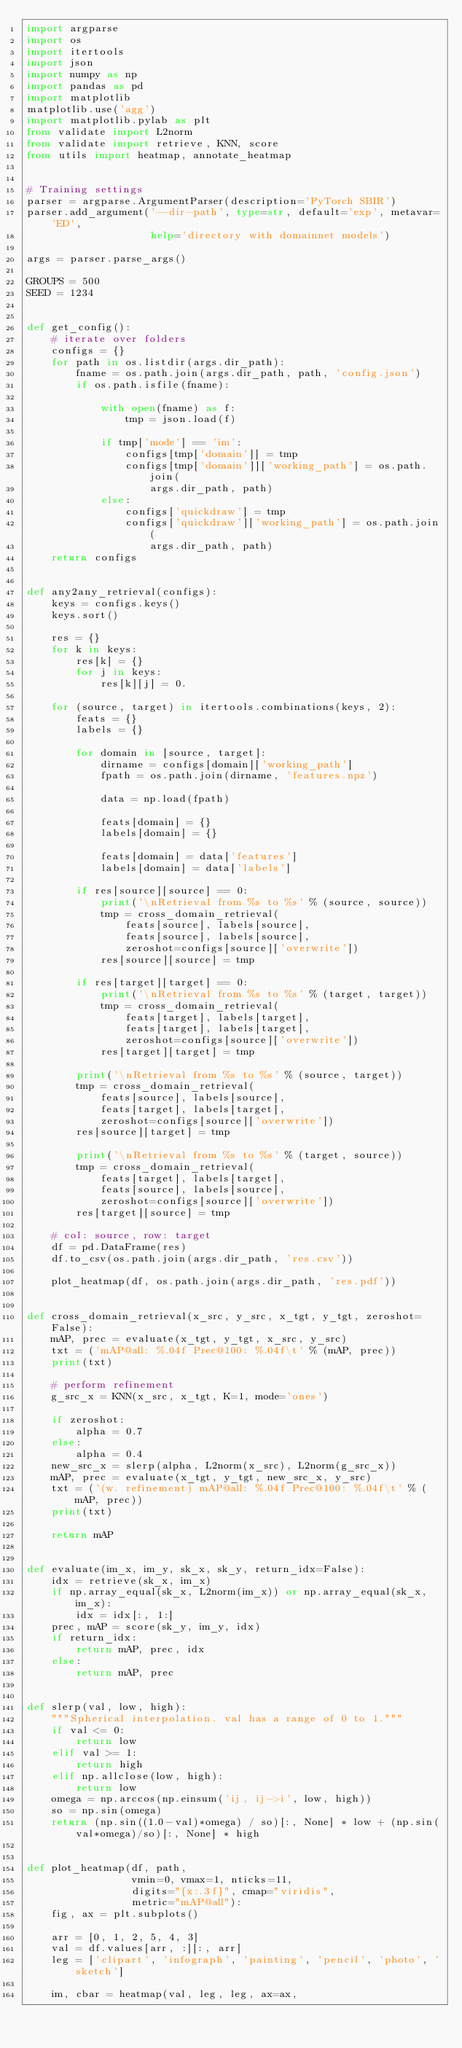Convert code to text. <code><loc_0><loc_0><loc_500><loc_500><_Python_>import argparse
import os
import itertools
import json
import numpy as np
import pandas as pd
import matplotlib
matplotlib.use('agg')
import matplotlib.pylab as plt
from validate import L2norm
from validate import retrieve, KNN, score
from utils import heatmap, annotate_heatmap


# Training settings
parser = argparse.ArgumentParser(description='PyTorch SBIR')
parser.add_argument('--dir-path', type=str, default='exp', metavar='ED',
                    help='directory with domainnet models')

args = parser.parse_args()

GROUPS = 500
SEED = 1234


def get_config():
    # iterate over folders
    configs = {}
    for path in os.listdir(args.dir_path):
        fname = os.path.join(args.dir_path, path, 'config.json')
        if os.path.isfile(fname):

            with open(fname) as f:
                tmp = json.load(f)

            if tmp['mode'] == 'im':
                configs[tmp['domain']] = tmp
                configs[tmp['domain']]['working_path'] = os.path.join(
                    args.dir_path, path)
            else:
                configs['quickdraw'] = tmp
                configs['quickdraw']['working_path'] = os.path.join(
                    args.dir_path, path)
    return configs


def any2any_retrieval(configs):
    keys = configs.keys()
    keys.sort()

    res = {}
    for k in keys:
        res[k] = {}
        for j in keys:
            res[k][j] = 0.

    for (source, target) in itertools.combinations(keys, 2):
        feats = {}
        labels = {}

        for domain in [source, target]:
            dirname = configs[domain]['working_path']
            fpath = os.path.join(dirname, 'features.npz')

            data = np.load(fpath)

            feats[domain] = {}
            labels[domain] = {}

            feats[domain] = data['features']
            labels[domain] = data['labels']

        if res[source][source] == 0:
            print('\nRetrieval from %s to %s' % (source, source))
            tmp = cross_domain_retrieval(
                feats[source], labels[source],
                feats[source], labels[source],
                zeroshot=configs[source]['overwrite'])
            res[source][source] = tmp

        if res[target][target] == 0:
            print('\nRetrieval from %s to %s' % (target, target))
            tmp = cross_domain_retrieval(
                feats[target], labels[target],
                feats[target], labels[target],
                zeroshot=configs[source]['overwrite'])
            res[target][target] = tmp

        print('\nRetrieval from %s to %s' % (source, target))
        tmp = cross_domain_retrieval(
            feats[source], labels[source],
            feats[target], labels[target],
            zeroshot=configs[source]['overwrite'])
        res[source][target] = tmp

        print('\nRetrieval from %s to %s' % (target, source))
        tmp = cross_domain_retrieval(
            feats[target], labels[target],
            feats[source], labels[source],
            zeroshot=configs[source]['overwrite'])
        res[target][source] = tmp

    # col: source, row: target
    df = pd.DataFrame(res)
    df.to_csv(os.path.join(args.dir_path, 'res.csv'))

    plot_heatmap(df, os.path.join(args.dir_path, 'res.pdf'))


def cross_domain_retrieval(x_src, y_src, x_tgt, y_tgt, zeroshot=False):
    mAP, prec = evaluate(x_tgt, y_tgt, x_src, y_src)
    txt = ('mAP@all: %.04f Prec@100: %.04f\t' % (mAP, prec))
    print(txt)

    # perform refinement
    g_src_x = KNN(x_src, x_tgt, K=1, mode='ones')

    if zeroshot:
        alpha = 0.7
    else:
        alpha = 0.4
    new_src_x = slerp(alpha, L2norm(x_src), L2norm(g_src_x))
    mAP, prec = evaluate(x_tgt, y_tgt, new_src_x, y_src)
    txt = ('(w. refinement) mAP@all: %.04f Prec@100: %.04f\t' % (mAP, prec))
    print(txt)

    return mAP


def evaluate(im_x, im_y, sk_x, sk_y, return_idx=False):
    idx = retrieve(sk_x, im_x)
    if np.array_equal(sk_x, L2norm(im_x)) or np.array_equal(sk_x, im_x):
        idx = idx[:, 1:]
    prec, mAP = score(sk_y, im_y, idx)
    if return_idx:
        return mAP, prec, idx
    else:
        return mAP, prec


def slerp(val, low, high):
    """Spherical interpolation. val has a range of 0 to 1."""
    if val <= 0:
        return low
    elif val >= 1:
        return high
    elif np.allclose(low, high):
        return low
    omega = np.arccos(np.einsum('ij, ij->i', low, high))
    so = np.sin(omega)
    return (np.sin((1.0-val)*omega) / so)[:, None] * low + (np.sin(val*omega)/so)[:, None] * high


def plot_heatmap(df, path,
                 vmin=0, vmax=1, nticks=11,
                 digits="{x:.3f}", cmap="viridis",
                 metric="mAP@all"):
    fig, ax = plt.subplots()

    arr = [0, 1, 2, 5, 4, 3]
    val = df.values[arr, :][:, arr]
    leg = ['clipart', 'infograph', 'painting', 'pencil', 'photo', 'sketch']

    im, cbar = heatmap(val, leg, leg, ax=ax,</code> 